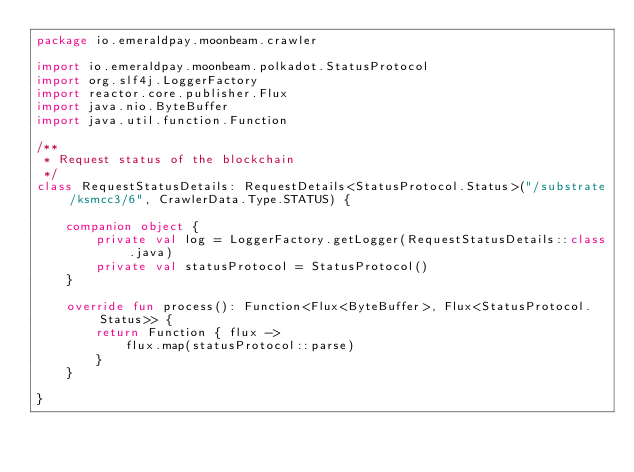<code> <loc_0><loc_0><loc_500><loc_500><_Kotlin_>package io.emeraldpay.moonbeam.crawler

import io.emeraldpay.moonbeam.polkadot.StatusProtocol
import org.slf4j.LoggerFactory
import reactor.core.publisher.Flux
import java.nio.ByteBuffer
import java.util.function.Function

/**
 * Request status of the blockchain
 */
class RequestStatusDetails: RequestDetails<StatusProtocol.Status>("/substrate/ksmcc3/6", CrawlerData.Type.STATUS) {

    companion object {
        private val log = LoggerFactory.getLogger(RequestStatusDetails::class.java)
        private val statusProtocol = StatusProtocol()
    }

    override fun process(): Function<Flux<ByteBuffer>, Flux<StatusProtocol.Status>> {
        return Function { flux ->
            flux.map(statusProtocol::parse)
        }
    }

}</code> 